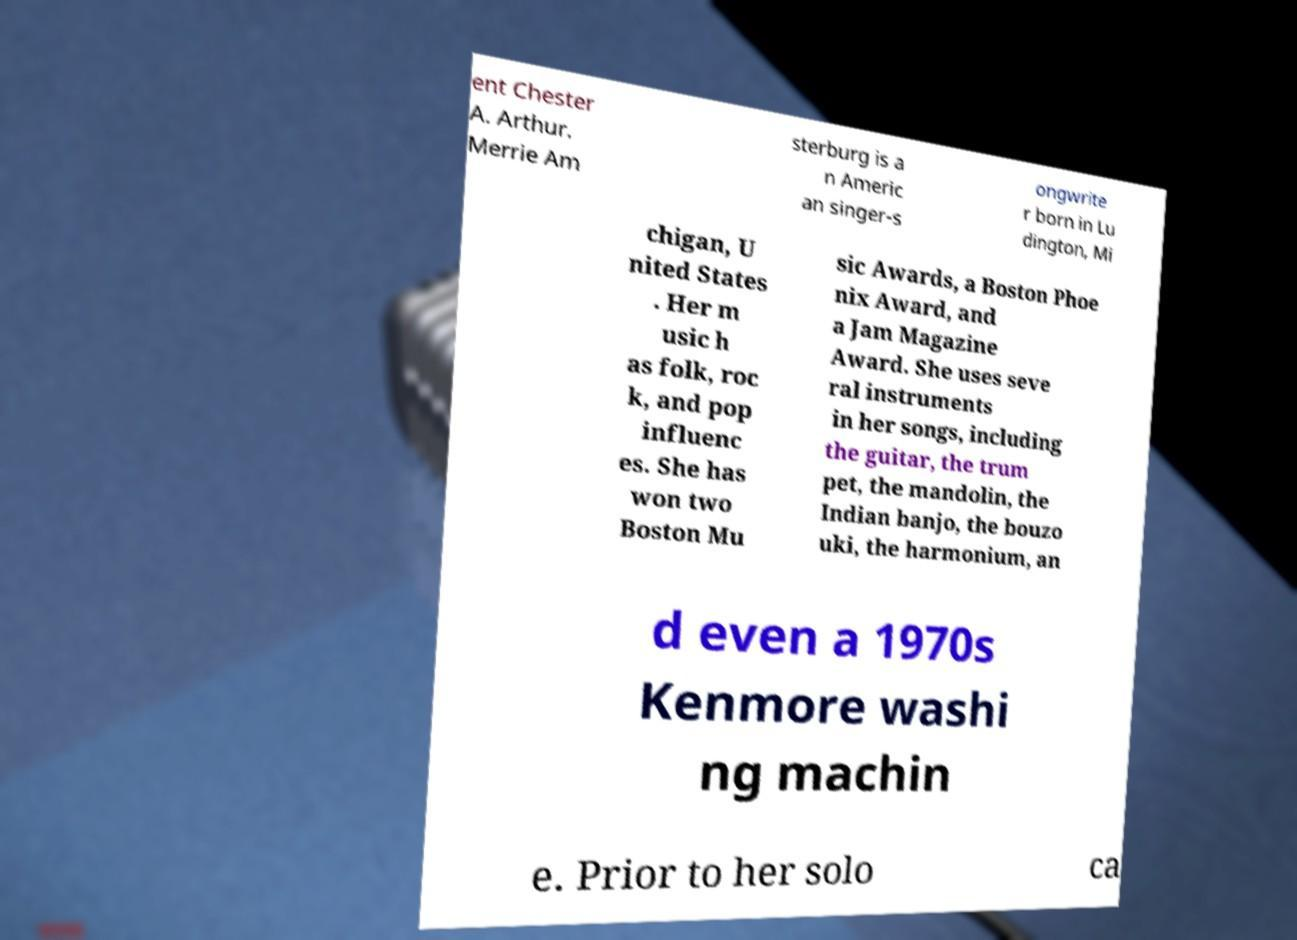Please identify and transcribe the text found in this image. ent Chester A. Arthur. Merrie Am sterburg is a n Americ an singer-s ongwrite r born in Lu dington, Mi chigan, U nited States . Her m usic h as folk, roc k, and pop influenc es. She has won two Boston Mu sic Awards, a Boston Phoe nix Award, and a Jam Magazine Award. She uses seve ral instruments in her songs, including the guitar, the trum pet, the mandolin, the Indian banjo, the bouzo uki, the harmonium, an d even a 1970s Kenmore washi ng machin e. Prior to her solo ca 